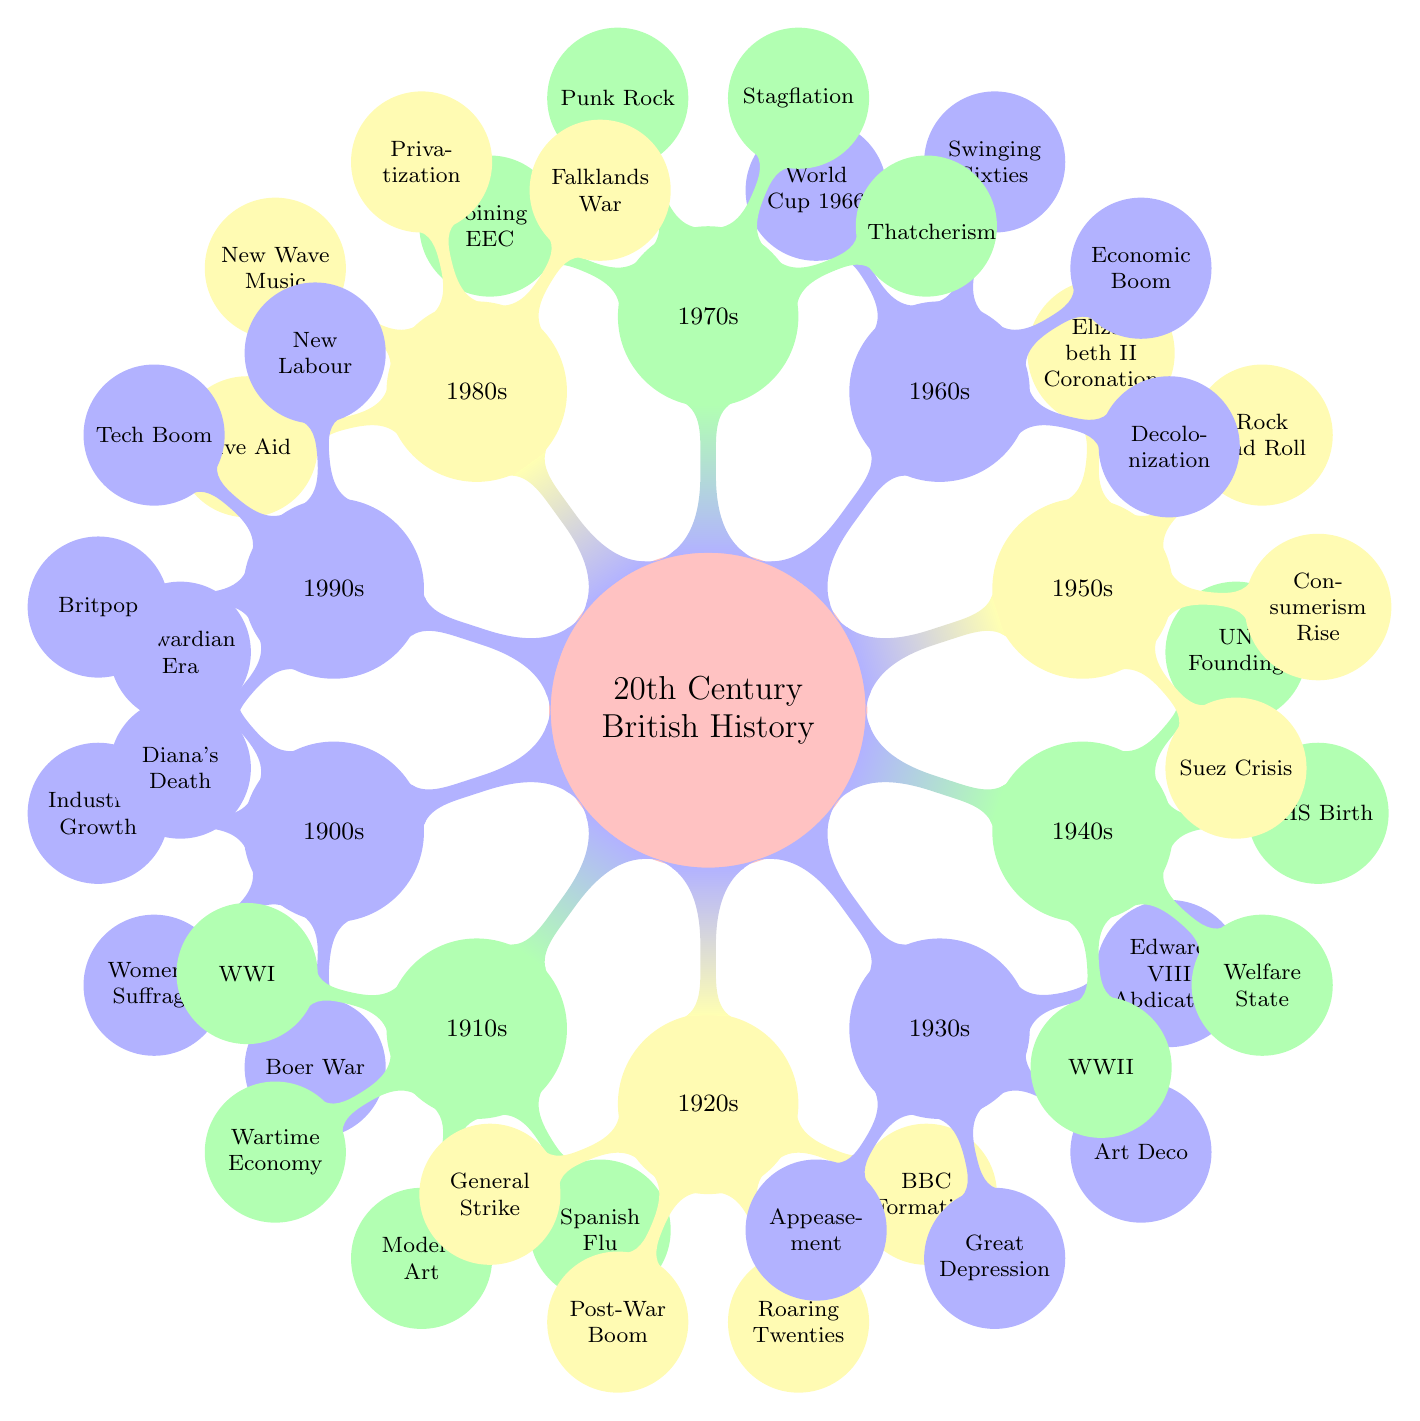What decade follows the 1940s in the diagram? The mind map shows a chronological flow, where each decade is listed in ascending order. After the section for the 1940s, the next labeled node is the 1950s.
Answer: 1950s What significant event is listed for the 1960s? Each decade in the diagram features significant events. For the 1960s, the notable event highlighted is the World Cup in 1966.
Answer: World Cup 1966 How many significant events are listed for the 1920s? By examining the sub-nodes under the 1920s, there are a total of four significant events mentioned: Formation of BBC, Women's Voting Rights Extended, General Strike of 1926, and Post-War Boom.
Answer: 4 Which cultural shift occurred during the 1930s? The diagram lists multiple cultural shifts for each decade. For the 1930s, the cultural shift identified is the Art Deco Movement.
Answer: Art Deco Movement What political change is associated with the 1980s? The 1980s section identifies two political changes. One of the key changes noted is Thatcher's Governments, which was a significant political trend during that decade.
Answer: Thatcher's Governments Why is the 1970s significant for economic developments? The 1970s list shows two important economic developments: Stagflation and the Oil Crisis. Both highlight challenging economic conditions during that decade. Notably, it's a time when economic distress was more pronounced.
Answer: Stagflation and Oil Crisis What genre of music is associated with the cultural shift in the 1950s? The mind map specifically denotes Rock and Roll as the cultural shift linked to the 1950s, indicating its emergence as a popular music genre during this time.
Answer: Rock and Roll What event marks the end of the 1980s? The significant event for the 1980s that stands out is the Live Aid Concert, which was a notable charitable event held in 1985.
Answer: Live Aid Concert 